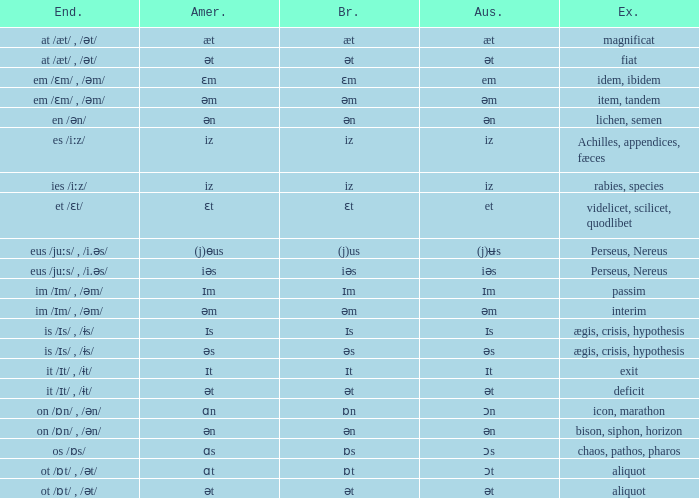Which Ending has British of iz, and Examples of achilles, appendices, fæces? Es /iːz/. 